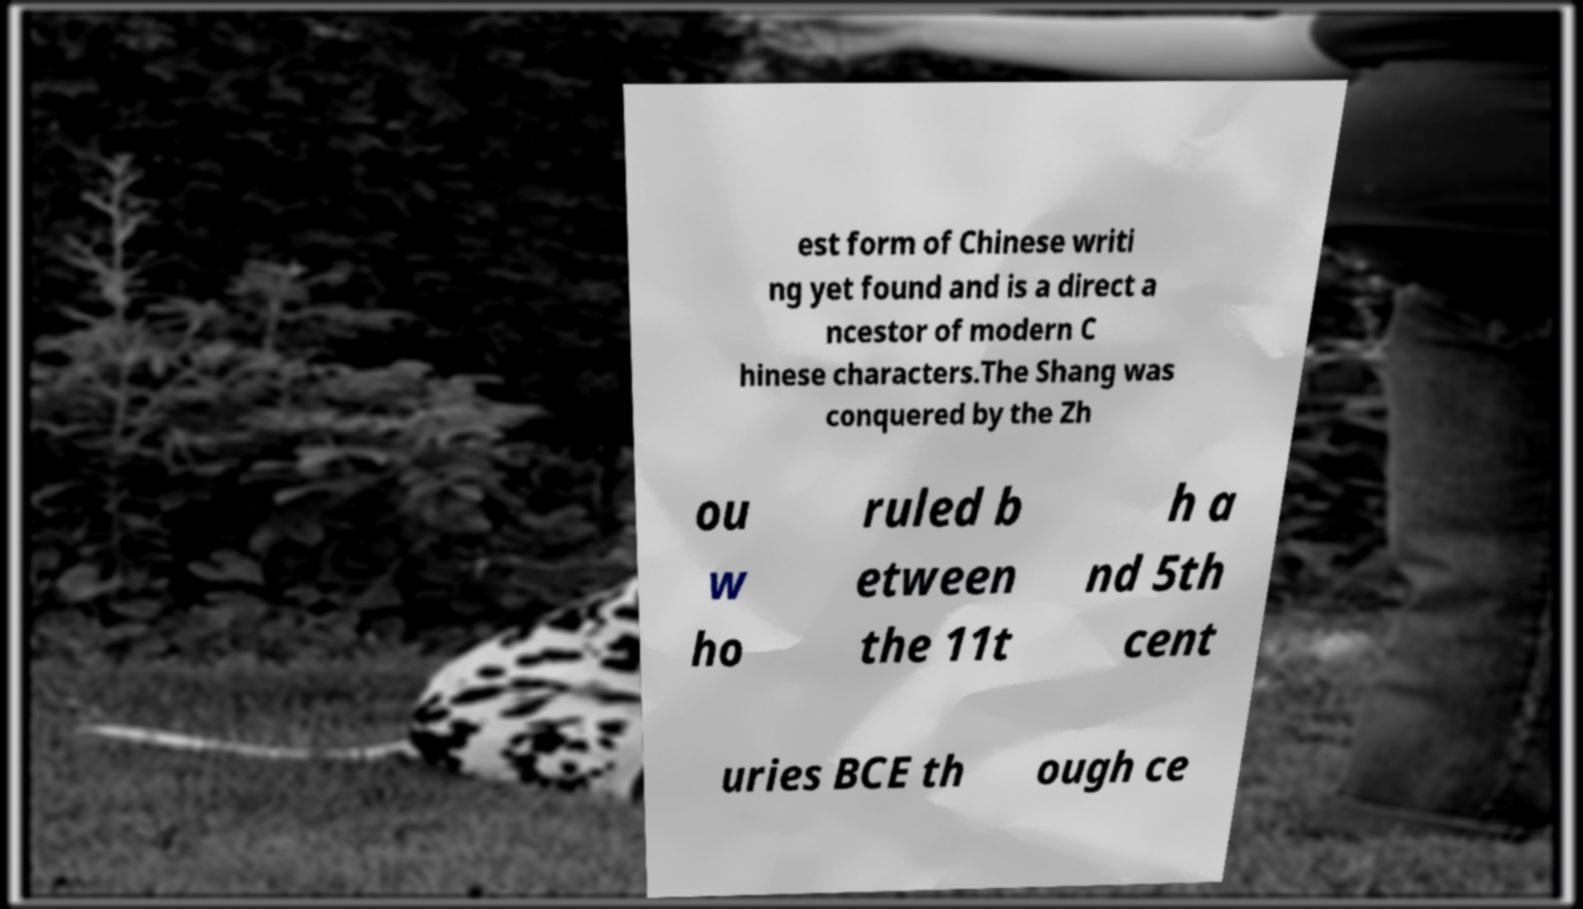For documentation purposes, I need the text within this image transcribed. Could you provide that? est form of Chinese writi ng yet found and is a direct a ncestor of modern C hinese characters.The Shang was conquered by the Zh ou w ho ruled b etween the 11t h a nd 5th cent uries BCE th ough ce 